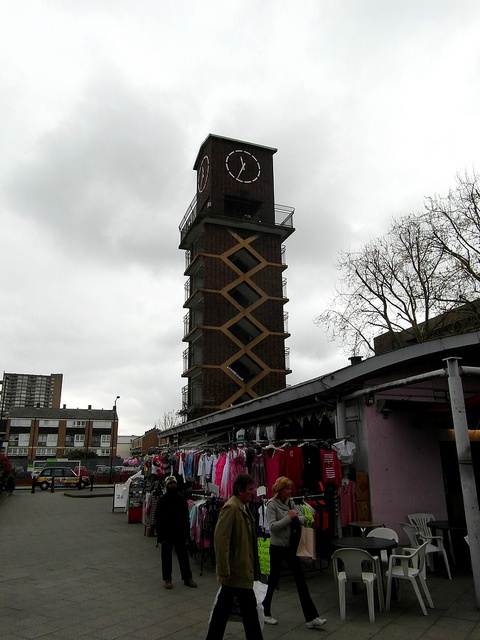Describe the objects in this image and their specific colors. I can see people in white, black, gray, and darkgreen tones, people in white, black, gray, maroon, and darkgreen tones, people in white, black, gray, purple, and teal tones, chair in white, black, and gray tones, and chair in white, black, and gray tones in this image. 